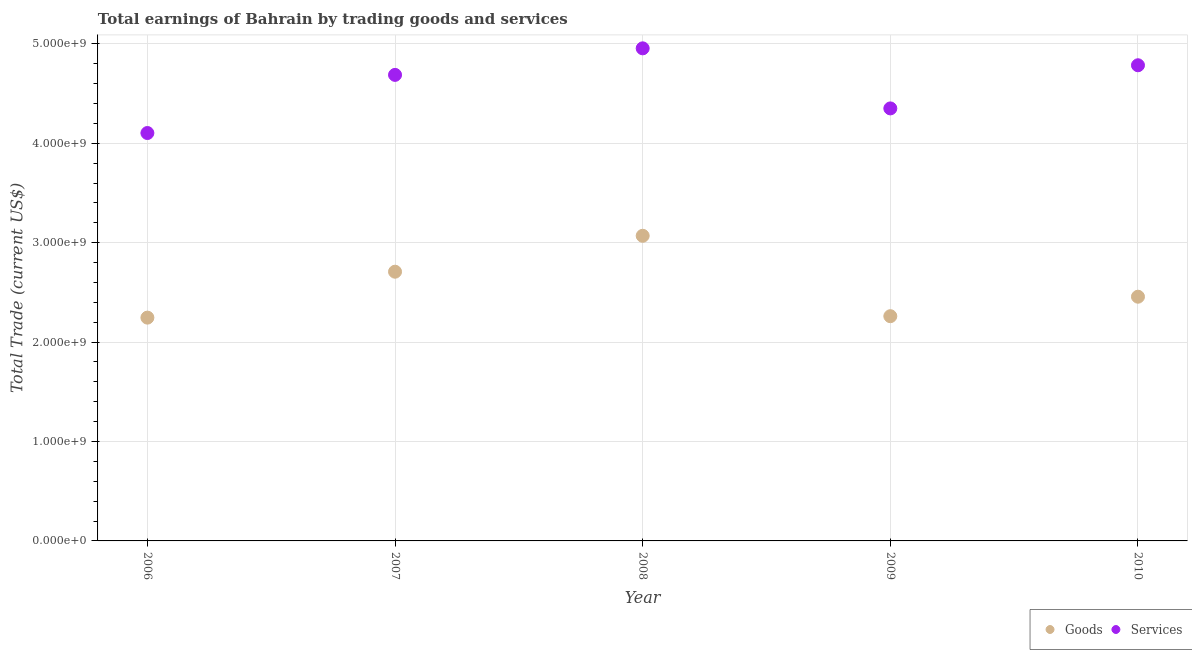Is the number of dotlines equal to the number of legend labels?
Offer a terse response. Yes. What is the amount earned by trading services in 2006?
Your response must be concise. 4.10e+09. Across all years, what is the maximum amount earned by trading goods?
Give a very brief answer. 3.07e+09. Across all years, what is the minimum amount earned by trading services?
Offer a terse response. 4.10e+09. What is the total amount earned by trading services in the graph?
Keep it short and to the point. 2.29e+1. What is the difference between the amount earned by trading goods in 2008 and that in 2010?
Provide a short and direct response. 6.13e+08. What is the difference between the amount earned by trading goods in 2010 and the amount earned by trading services in 2008?
Keep it short and to the point. -2.50e+09. What is the average amount earned by trading services per year?
Ensure brevity in your answer.  4.58e+09. In the year 2007, what is the difference between the amount earned by trading goods and amount earned by trading services?
Offer a very short reply. -1.98e+09. In how many years, is the amount earned by trading services greater than 4800000000 US$?
Give a very brief answer. 1. What is the ratio of the amount earned by trading goods in 2008 to that in 2009?
Make the answer very short. 1.36. What is the difference between the highest and the second highest amount earned by trading goods?
Provide a succinct answer. 3.61e+08. What is the difference between the highest and the lowest amount earned by trading services?
Offer a terse response. 8.52e+08. Is the sum of the amount earned by trading goods in 2006 and 2010 greater than the maximum amount earned by trading services across all years?
Make the answer very short. No. Is the amount earned by trading services strictly less than the amount earned by trading goods over the years?
Provide a succinct answer. No. How many dotlines are there?
Offer a terse response. 2. How many years are there in the graph?
Your response must be concise. 5. Are the values on the major ticks of Y-axis written in scientific E-notation?
Ensure brevity in your answer.  Yes. Does the graph contain any zero values?
Provide a succinct answer. No. Does the graph contain grids?
Offer a very short reply. Yes. How many legend labels are there?
Your answer should be very brief. 2. How are the legend labels stacked?
Offer a very short reply. Horizontal. What is the title of the graph?
Offer a very short reply. Total earnings of Bahrain by trading goods and services. Does "Import" appear as one of the legend labels in the graph?
Keep it short and to the point. No. What is the label or title of the X-axis?
Offer a terse response. Year. What is the label or title of the Y-axis?
Provide a short and direct response. Total Trade (current US$). What is the Total Trade (current US$) of Goods in 2006?
Provide a short and direct response. 2.25e+09. What is the Total Trade (current US$) of Services in 2006?
Keep it short and to the point. 4.10e+09. What is the Total Trade (current US$) in Goods in 2007?
Provide a short and direct response. 2.71e+09. What is the Total Trade (current US$) in Services in 2007?
Keep it short and to the point. 4.69e+09. What is the Total Trade (current US$) in Goods in 2008?
Give a very brief answer. 3.07e+09. What is the Total Trade (current US$) in Services in 2008?
Offer a very short reply. 4.96e+09. What is the Total Trade (current US$) in Goods in 2009?
Ensure brevity in your answer.  2.26e+09. What is the Total Trade (current US$) in Services in 2009?
Ensure brevity in your answer.  4.35e+09. What is the Total Trade (current US$) in Goods in 2010?
Provide a short and direct response. 2.46e+09. What is the Total Trade (current US$) in Services in 2010?
Your response must be concise. 4.78e+09. Across all years, what is the maximum Total Trade (current US$) of Goods?
Provide a succinct answer. 3.07e+09. Across all years, what is the maximum Total Trade (current US$) in Services?
Your answer should be compact. 4.96e+09. Across all years, what is the minimum Total Trade (current US$) in Goods?
Ensure brevity in your answer.  2.25e+09. Across all years, what is the minimum Total Trade (current US$) in Services?
Offer a very short reply. 4.10e+09. What is the total Total Trade (current US$) in Goods in the graph?
Provide a short and direct response. 1.27e+1. What is the total Total Trade (current US$) of Services in the graph?
Provide a short and direct response. 2.29e+1. What is the difference between the Total Trade (current US$) in Goods in 2006 and that in 2007?
Provide a short and direct response. -4.62e+08. What is the difference between the Total Trade (current US$) in Services in 2006 and that in 2007?
Your answer should be very brief. -5.85e+08. What is the difference between the Total Trade (current US$) of Goods in 2006 and that in 2008?
Keep it short and to the point. -8.23e+08. What is the difference between the Total Trade (current US$) in Services in 2006 and that in 2008?
Give a very brief answer. -8.52e+08. What is the difference between the Total Trade (current US$) of Goods in 2006 and that in 2009?
Provide a short and direct response. -1.44e+07. What is the difference between the Total Trade (current US$) of Services in 2006 and that in 2009?
Your response must be concise. -2.48e+08. What is the difference between the Total Trade (current US$) in Goods in 2006 and that in 2010?
Ensure brevity in your answer.  -2.10e+08. What is the difference between the Total Trade (current US$) of Services in 2006 and that in 2010?
Your answer should be compact. -6.82e+08. What is the difference between the Total Trade (current US$) of Goods in 2007 and that in 2008?
Provide a short and direct response. -3.61e+08. What is the difference between the Total Trade (current US$) in Services in 2007 and that in 2008?
Offer a very short reply. -2.67e+08. What is the difference between the Total Trade (current US$) of Goods in 2007 and that in 2009?
Make the answer very short. 4.47e+08. What is the difference between the Total Trade (current US$) of Services in 2007 and that in 2009?
Your answer should be very brief. 3.37e+08. What is the difference between the Total Trade (current US$) in Goods in 2007 and that in 2010?
Give a very brief answer. 2.51e+08. What is the difference between the Total Trade (current US$) in Services in 2007 and that in 2010?
Provide a short and direct response. -9.68e+07. What is the difference between the Total Trade (current US$) of Goods in 2008 and that in 2009?
Your answer should be very brief. 8.09e+08. What is the difference between the Total Trade (current US$) of Services in 2008 and that in 2009?
Provide a succinct answer. 6.04e+08. What is the difference between the Total Trade (current US$) of Goods in 2008 and that in 2010?
Keep it short and to the point. 6.13e+08. What is the difference between the Total Trade (current US$) in Services in 2008 and that in 2010?
Provide a succinct answer. 1.70e+08. What is the difference between the Total Trade (current US$) in Goods in 2009 and that in 2010?
Your answer should be very brief. -1.96e+08. What is the difference between the Total Trade (current US$) in Services in 2009 and that in 2010?
Ensure brevity in your answer.  -4.34e+08. What is the difference between the Total Trade (current US$) of Goods in 2006 and the Total Trade (current US$) of Services in 2007?
Give a very brief answer. -2.44e+09. What is the difference between the Total Trade (current US$) of Goods in 2006 and the Total Trade (current US$) of Services in 2008?
Make the answer very short. -2.71e+09. What is the difference between the Total Trade (current US$) in Goods in 2006 and the Total Trade (current US$) in Services in 2009?
Offer a terse response. -2.10e+09. What is the difference between the Total Trade (current US$) in Goods in 2006 and the Total Trade (current US$) in Services in 2010?
Offer a very short reply. -2.54e+09. What is the difference between the Total Trade (current US$) of Goods in 2007 and the Total Trade (current US$) of Services in 2008?
Your response must be concise. -2.25e+09. What is the difference between the Total Trade (current US$) in Goods in 2007 and the Total Trade (current US$) in Services in 2009?
Your answer should be very brief. -1.64e+09. What is the difference between the Total Trade (current US$) in Goods in 2007 and the Total Trade (current US$) in Services in 2010?
Offer a very short reply. -2.08e+09. What is the difference between the Total Trade (current US$) of Goods in 2008 and the Total Trade (current US$) of Services in 2009?
Provide a succinct answer. -1.28e+09. What is the difference between the Total Trade (current US$) in Goods in 2008 and the Total Trade (current US$) in Services in 2010?
Provide a succinct answer. -1.72e+09. What is the difference between the Total Trade (current US$) of Goods in 2009 and the Total Trade (current US$) of Services in 2010?
Your answer should be compact. -2.52e+09. What is the average Total Trade (current US$) of Goods per year?
Your answer should be very brief. 2.55e+09. What is the average Total Trade (current US$) in Services per year?
Keep it short and to the point. 4.58e+09. In the year 2006, what is the difference between the Total Trade (current US$) in Goods and Total Trade (current US$) in Services?
Offer a very short reply. -1.86e+09. In the year 2007, what is the difference between the Total Trade (current US$) of Goods and Total Trade (current US$) of Services?
Your response must be concise. -1.98e+09. In the year 2008, what is the difference between the Total Trade (current US$) of Goods and Total Trade (current US$) of Services?
Your response must be concise. -1.89e+09. In the year 2009, what is the difference between the Total Trade (current US$) in Goods and Total Trade (current US$) in Services?
Keep it short and to the point. -2.09e+09. In the year 2010, what is the difference between the Total Trade (current US$) in Goods and Total Trade (current US$) in Services?
Keep it short and to the point. -2.33e+09. What is the ratio of the Total Trade (current US$) of Goods in 2006 to that in 2007?
Ensure brevity in your answer.  0.83. What is the ratio of the Total Trade (current US$) in Services in 2006 to that in 2007?
Your answer should be compact. 0.88. What is the ratio of the Total Trade (current US$) in Goods in 2006 to that in 2008?
Your answer should be compact. 0.73. What is the ratio of the Total Trade (current US$) of Services in 2006 to that in 2008?
Provide a succinct answer. 0.83. What is the ratio of the Total Trade (current US$) of Goods in 2006 to that in 2009?
Keep it short and to the point. 0.99. What is the ratio of the Total Trade (current US$) in Services in 2006 to that in 2009?
Offer a very short reply. 0.94. What is the ratio of the Total Trade (current US$) of Goods in 2006 to that in 2010?
Make the answer very short. 0.91. What is the ratio of the Total Trade (current US$) in Services in 2006 to that in 2010?
Offer a terse response. 0.86. What is the ratio of the Total Trade (current US$) of Goods in 2007 to that in 2008?
Give a very brief answer. 0.88. What is the ratio of the Total Trade (current US$) in Services in 2007 to that in 2008?
Offer a terse response. 0.95. What is the ratio of the Total Trade (current US$) of Goods in 2007 to that in 2009?
Your answer should be compact. 1.2. What is the ratio of the Total Trade (current US$) of Services in 2007 to that in 2009?
Keep it short and to the point. 1.08. What is the ratio of the Total Trade (current US$) of Goods in 2007 to that in 2010?
Give a very brief answer. 1.1. What is the ratio of the Total Trade (current US$) in Services in 2007 to that in 2010?
Provide a short and direct response. 0.98. What is the ratio of the Total Trade (current US$) of Goods in 2008 to that in 2009?
Your answer should be very brief. 1.36. What is the ratio of the Total Trade (current US$) in Services in 2008 to that in 2009?
Your response must be concise. 1.14. What is the ratio of the Total Trade (current US$) in Goods in 2008 to that in 2010?
Provide a succinct answer. 1.25. What is the ratio of the Total Trade (current US$) in Services in 2008 to that in 2010?
Offer a very short reply. 1.04. What is the ratio of the Total Trade (current US$) of Goods in 2009 to that in 2010?
Ensure brevity in your answer.  0.92. What is the ratio of the Total Trade (current US$) of Services in 2009 to that in 2010?
Keep it short and to the point. 0.91. What is the difference between the highest and the second highest Total Trade (current US$) in Goods?
Offer a very short reply. 3.61e+08. What is the difference between the highest and the second highest Total Trade (current US$) of Services?
Your answer should be very brief. 1.70e+08. What is the difference between the highest and the lowest Total Trade (current US$) of Goods?
Offer a very short reply. 8.23e+08. What is the difference between the highest and the lowest Total Trade (current US$) in Services?
Ensure brevity in your answer.  8.52e+08. 